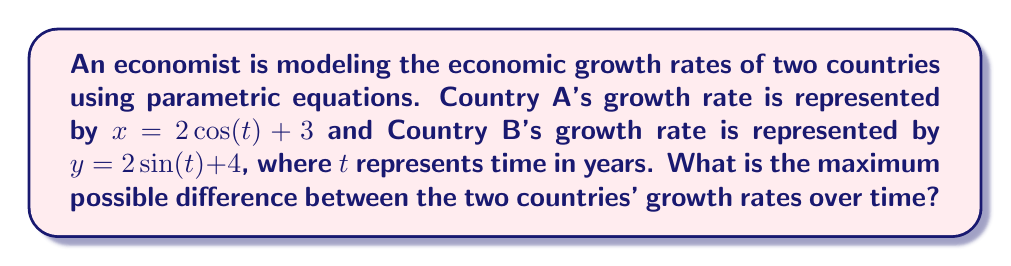Teach me how to tackle this problem. To solve this problem, we need to follow these steps:

1) The difference between the two growth rates at any given time $t$ is:
   $$D(t) = y - x = (2\sin(t) + 4) - (2\cos(t) + 3) = 2\sin(t) - 2\cos(t) + 1$$

2) We can simplify this expression using the trigonometric identity:
   $$a\sin(t) + b\cos(t) = \sqrt{a^2 + b^2} \sin(t + \phi)$$
   where $\phi = \arctan(\frac{b}{a})$

3) In our case, $a = 2$ and $b = -2$, so:
   $$D(t) = \sqrt{2^2 + (-2)^2} \sin(t + \phi) + 1 = 2\sqrt{2} \sin(t + \phi) + 1$$
   where $\phi = \arctan(\frac{-2}{2}) = -\frac{\pi}{4}$

4) The maximum value of $\sin(t + \phi)$ is 1, and its minimum value is -1.

5) Therefore, the maximum value of $D(t)$ occurs when $\sin(t + \phi) = 1$:
   $$D_{max} = 2\sqrt{2} \cdot 1 + 1 = 2\sqrt{2} + 1$$

6) The minimum value of $D(t)$ occurs when $\sin(t + \phi) = -1$:
   $$D_{min} = 2\sqrt{2} \cdot (-1) + 1 = -2\sqrt{2} + 1$$

7) The maximum difference between the two growth rates is the difference between $D_{max}$ and $D_{min}$:
   $$\text{Max Difference} = D_{max} - D_{min} = (2\sqrt{2} + 1) - (-2\sqrt{2} + 1) = 4\sqrt{2}$$
Answer: The maximum possible difference between the two countries' growth rates over time is $4\sqrt{2}$. 